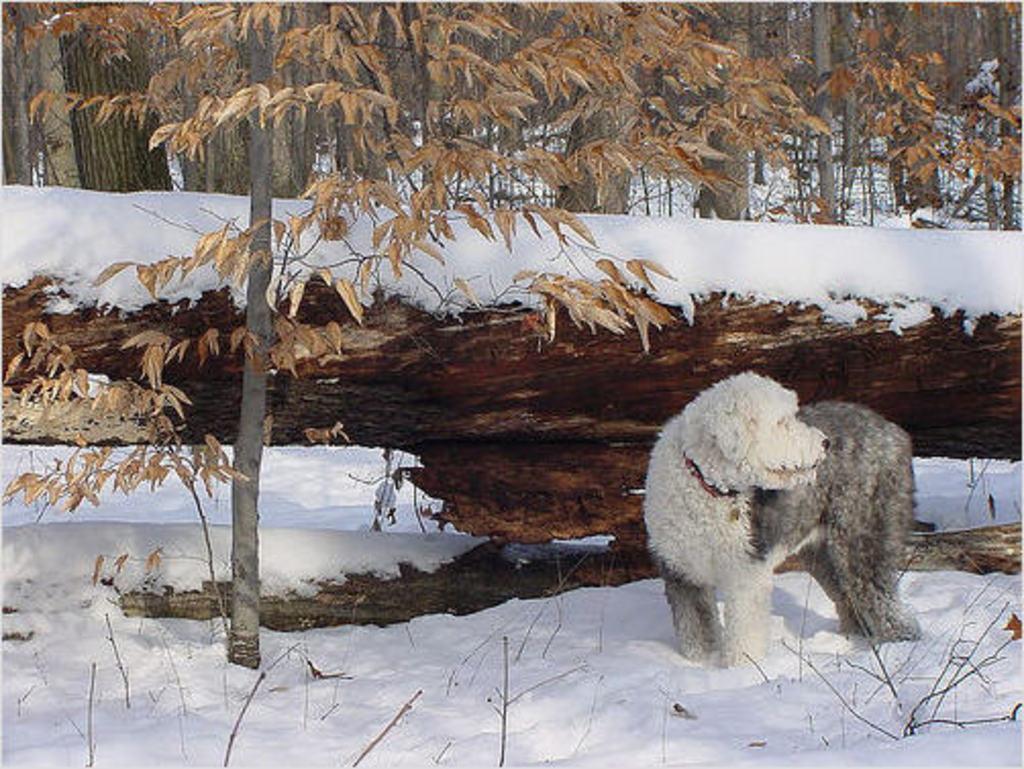Describe this image in one or two sentences. In the foreground of the picture there are twigs, plant, dog and soil and there is snow also. In the center of the picture there is snow. In the background there are trees. 